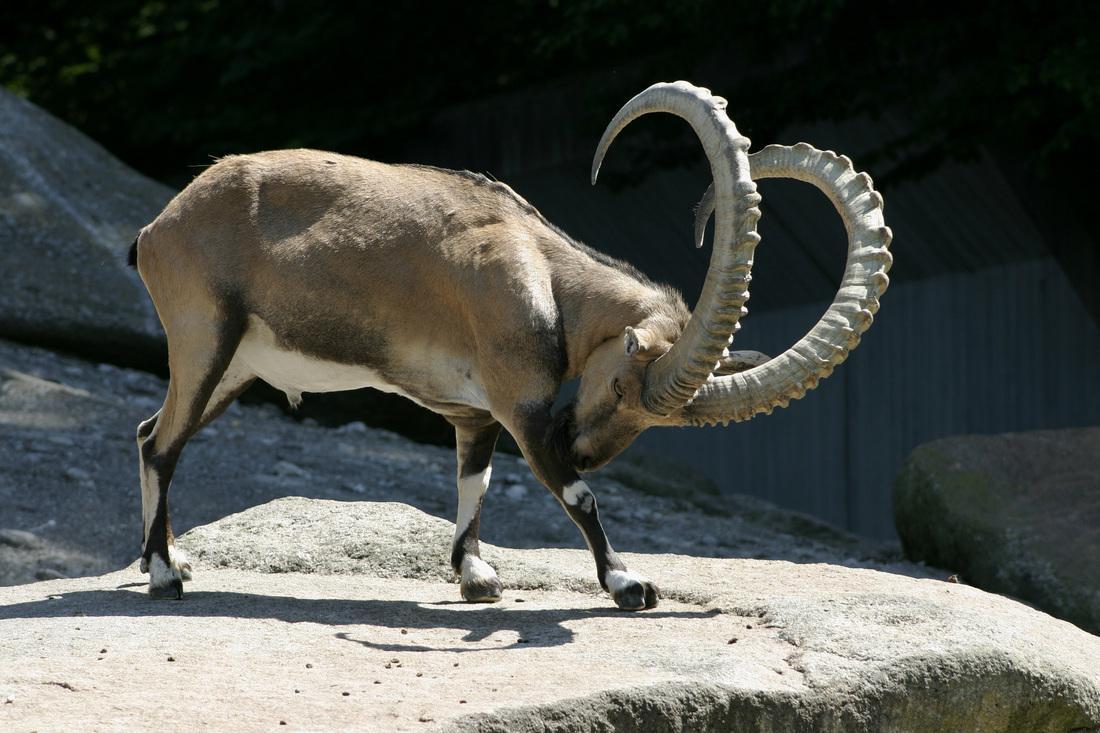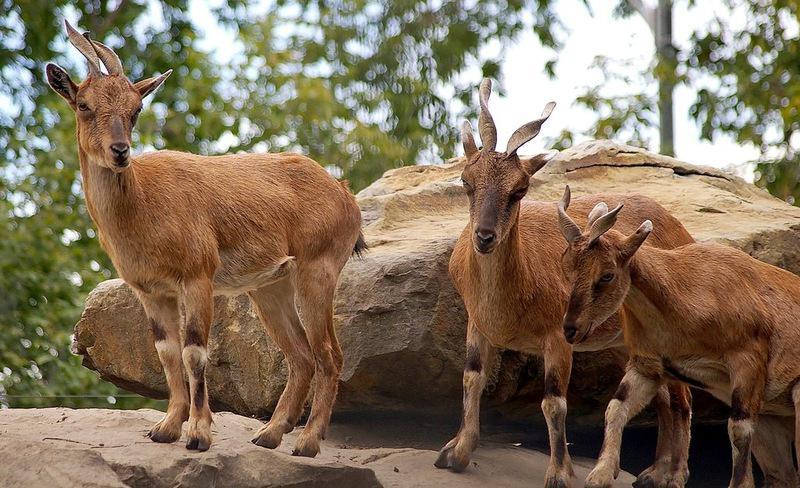The first image is the image on the left, the second image is the image on the right. Given the left and right images, does the statement "There is a total of four animals." hold true? Answer yes or no. Yes. 